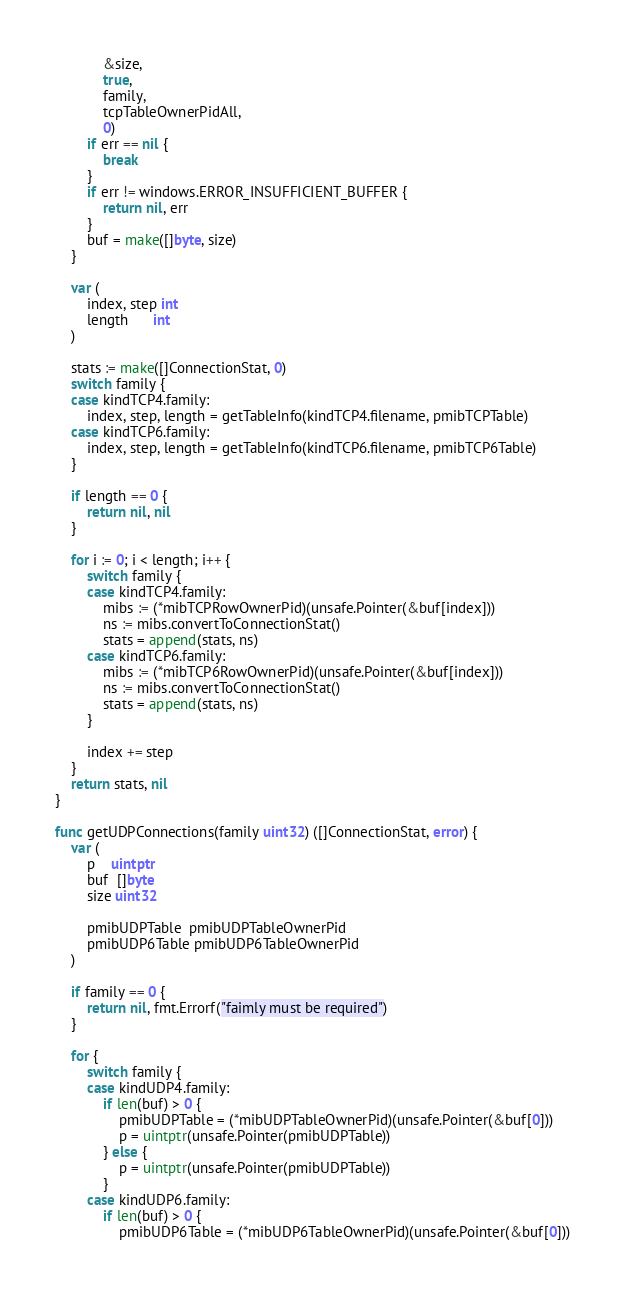<code> <loc_0><loc_0><loc_500><loc_500><_Go_>			&size,
			true,
			family,
			tcpTableOwnerPidAll,
			0)
		if err == nil {
			break
		}
		if err != windows.ERROR_INSUFFICIENT_BUFFER {
			return nil, err
		}
		buf = make([]byte, size)
	}

	var (
		index, step int
		length      int
	)

	stats := make([]ConnectionStat, 0)
	switch family {
	case kindTCP4.family:
		index, step, length = getTableInfo(kindTCP4.filename, pmibTCPTable)
	case kindTCP6.family:
		index, step, length = getTableInfo(kindTCP6.filename, pmibTCP6Table)
	}

	if length == 0 {
		return nil, nil
	}

	for i := 0; i < length; i++ {
		switch family {
		case kindTCP4.family:
			mibs := (*mibTCPRowOwnerPid)(unsafe.Pointer(&buf[index]))
			ns := mibs.convertToConnectionStat()
			stats = append(stats, ns)
		case kindTCP6.family:
			mibs := (*mibTCP6RowOwnerPid)(unsafe.Pointer(&buf[index]))
			ns := mibs.convertToConnectionStat()
			stats = append(stats, ns)
		}

		index += step
	}
	return stats, nil
}

func getUDPConnections(family uint32) ([]ConnectionStat, error) {
	var (
		p    uintptr
		buf  []byte
		size uint32

		pmibUDPTable  pmibUDPTableOwnerPid
		pmibUDP6Table pmibUDP6TableOwnerPid
	)

	if family == 0 {
		return nil, fmt.Errorf("faimly must be required")
	}

	for {
		switch family {
		case kindUDP4.family:
			if len(buf) > 0 {
				pmibUDPTable = (*mibUDPTableOwnerPid)(unsafe.Pointer(&buf[0]))
				p = uintptr(unsafe.Pointer(pmibUDPTable))
			} else {
				p = uintptr(unsafe.Pointer(pmibUDPTable))
			}
		case kindUDP6.family:
			if len(buf) > 0 {
				pmibUDP6Table = (*mibUDP6TableOwnerPid)(unsafe.Pointer(&buf[0]))</code> 